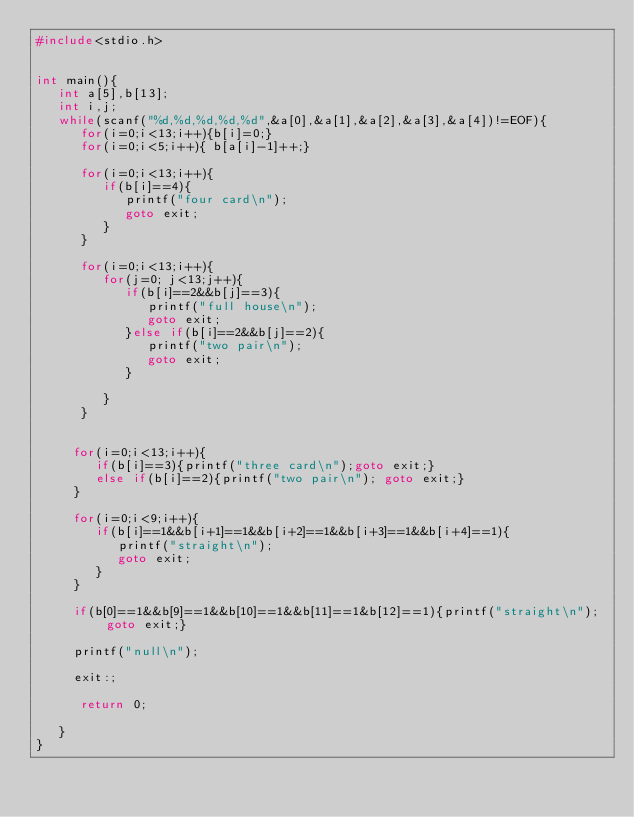Convert code to text. <code><loc_0><loc_0><loc_500><loc_500><_C_>#include<stdio.h>


int main(){
   int a[5],b[13];
   int i,j;
   while(scanf("%d,%d,%d,%d,%d",&a[0],&a[1],&a[2],&a[3],&a[4])!=EOF){
      for(i=0;i<13;i++){b[i]=0;}
      for(i=0;i<5;i++){ b[a[i]-1]++;}
      
      for(i=0;i<13;i++){
         if(b[i]==4){
            printf("four card\n");
            goto exit;
         }
      }

      for(i=0;i<13;i++){
         for(j=0; j<13;j++){
            if(b[i]==2&&b[j]==3){
               printf("full house\n");
               goto exit;
            }else if(b[i]==2&&b[j]==2){
               printf("two pair\n");
               goto exit;
            }
            
         }
      }


     for(i=0;i<13;i++){
        if(b[i]==3){printf("three card\n");goto exit;}
        else if(b[i]==2){printf("two pair\n"); goto exit;}
     }

     for(i=0;i<9;i++){
        if(b[i]==1&&b[i+1]==1&&b[i+2]==1&&b[i+3]==1&&b[i+4]==1){
           printf("straight\n");
           goto exit;
        }
     }

     if(b[0]==1&&b[9]==1&&b[10]==1&&b[11]==1&b[12]==1){printf("straight\n"); goto exit;}

     printf("null\n");

     exit:;
      
      return 0;
     
   }
}</code> 